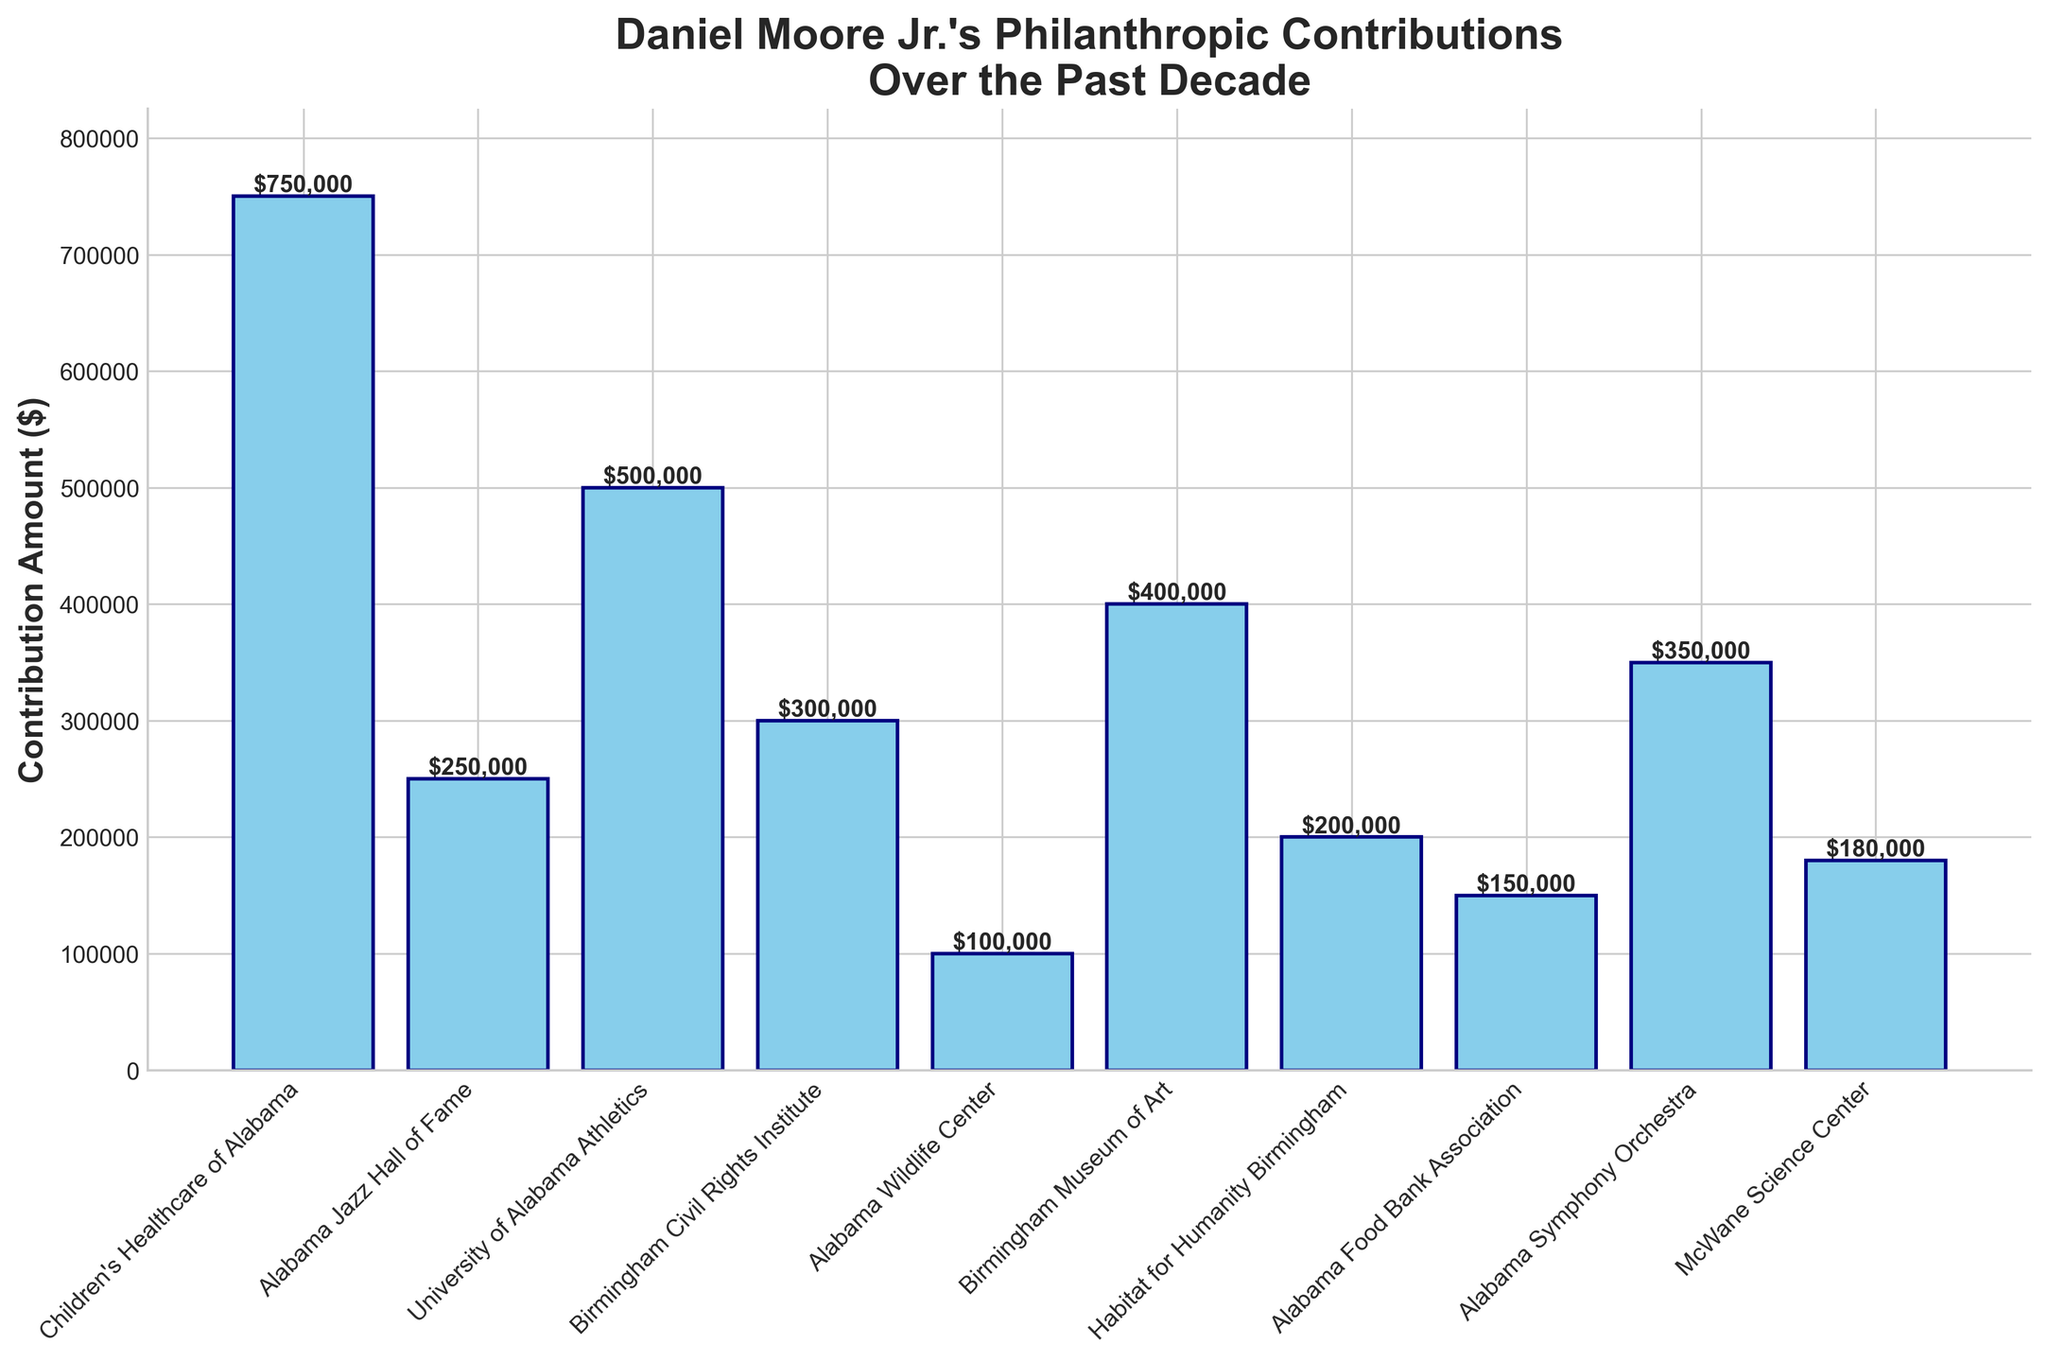Which cause received the highest contribution? The tallest bar represents the highest contribution. The bar for "Children's Healthcare of Alabama" is the tallest with a contribution of $750,000.
Answer: Children's Healthcare of Alabama How much more did Daniel contribute to the Birmingham Museum of Art compared to the Alabama Wildlife Center? The contribution to the Birmingham Museum of Art is $400,000, and the contribution to the Alabama Wildlife Center is $100,000. The difference between them is $400,000 - $100,000 = $300,000.
Answer: $300,000 What is the total amount contributed to the University of Alabama Athletics and the Alabama Symphony Orchestra? The contribution to the University of Alabama Athletics is $500,000 and to the Alabama Symphony Orchestra is $350,000. The total is $500,000 + $350,000 = $850,000.
Answer: $850,000 Which three causes received the least contributions? The three shortest bars correspond to the least contributions. They are "Alabama Wildlife Center" ($100,000), "Alabama Food Bank Association" ($150,000), and "McWane Science Center" ($180,000).
Answer: Alabama Wildlife Center, Alabama Food Bank Association, McWane Science Center How much did Daniel contribute to the Birmingham Civil Rights Institute? The contribution to the Birmingham Civil Rights Institute is displayed on the bar chart as $300,000.
Answer: $300,000 Is the contribution to the Habitat for Humanity Birmingham greater or smaller than to the Alabama Jazz Hall of Fame, and by how much? The contribution to Habitat for Humanity Birmingham is $200,000 while to the Alabama Jazz Hall of Fame is $250,000. The contribution to Habitat for Humanity Birmingham is smaller by $50,000.
Answer: Smaller by $50,000 What is the average contribution amount based on the data provided? Summing all contribution amounts: $750,000 + $250,000 + $500,000 + $300,000 + $100,000 + $400,000 + $200,000 + $150,000 + $350,000 + $180,000 = $3,180,000. There are 10 causes, so the average contribution is $3,180,000 / 10 = $318,000.
Answer: $318,000 How much more is the contribution to Children's Healthcare of Alabama compared to the Alabama Jazz Hall of Fame and the University of Alabama Athletics combined? The contribution to Children's Healthcare of Alabama is $750,000. The combined contribution to the Alabama Jazz Hall of Fame and University of Alabama Athletics is $250,000 + $500,000 = $750,000. The difference is $750,000 - $750,000 = $0.
Answer: $0 